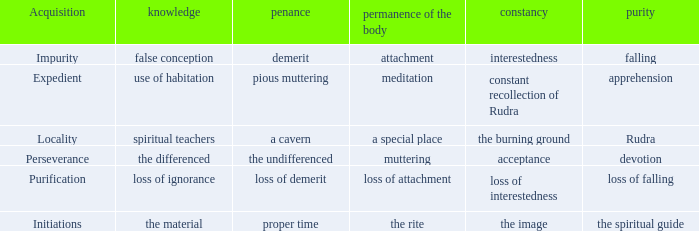What is the endurance of the body in which purity is identified as rudra? A special place. Parse the table in full. {'header': ['Acquisition', 'knowledge', 'penance', 'permanence of the body', 'constancy', 'purity'], 'rows': [['Impurity', 'false conception', 'demerit', 'attachment', 'interestedness', 'falling'], ['Expedient', 'use of habitation', 'pious muttering', 'meditation', 'constant recollection of Rudra', 'apprehension'], ['Locality', 'spiritual teachers', 'a cavern', 'a special place', 'the burning ground', 'Rudra'], ['Perseverance', 'the differenced', 'the undifferenced', 'muttering', 'acceptance', 'devotion'], ['Purification', 'loss of ignorance', 'loss of demerit', 'loss of attachment', 'loss of interestedness', 'loss of falling'], ['Initiations', 'the material', 'proper time', 'the rite', 'the image', 'the spiritual guide']]} 